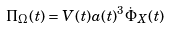<formula> <loc_0><loc_0><loc_500><loc_500>\Pi _ { \Omega } ( t ) = V ( t ) a ( t ) ^ { 3 } \dot { \Phi } _ { X } ( t )</formula> 